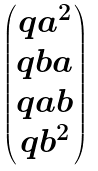Convert formula to latex. <formula><loc_0><loc_0><loc_500><loc_500>\begin{pmatrix} q a ^ { 2 } \\ q b a \\ q a b \\ q b ^ { 2 } \end{pmatrix}</formula> 